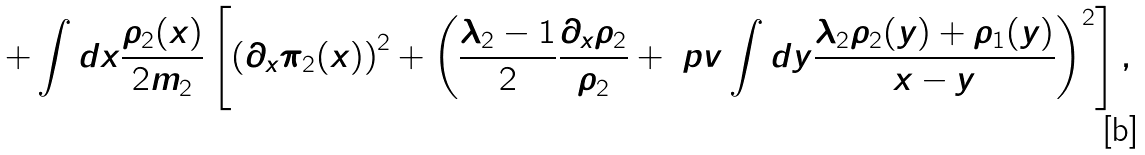<formula> <loc_0><loc_0><loc_500><loc_500>+ \int d x \frac { \rho _ { 2 } ( x ) } { 2 m _ { 2 } } \left [ { ( \partial _ { x } \pi _ { 2 } ( x ) ) } ^ { 2 } + { \left ( \frac { \lambda _ { 2 } - 1 } { 2 } \frac { \partial _ { x } \rho _ { 2 } } { \rho _ { 2 } } + \ p v \int d y \frac { \lambda _ { 2 } \rho _ { 2 } ( y ) + \rho _ { 1 } ( y ) } { x - y } \right ) } ^ { 2 } \right ] ,</formula> 